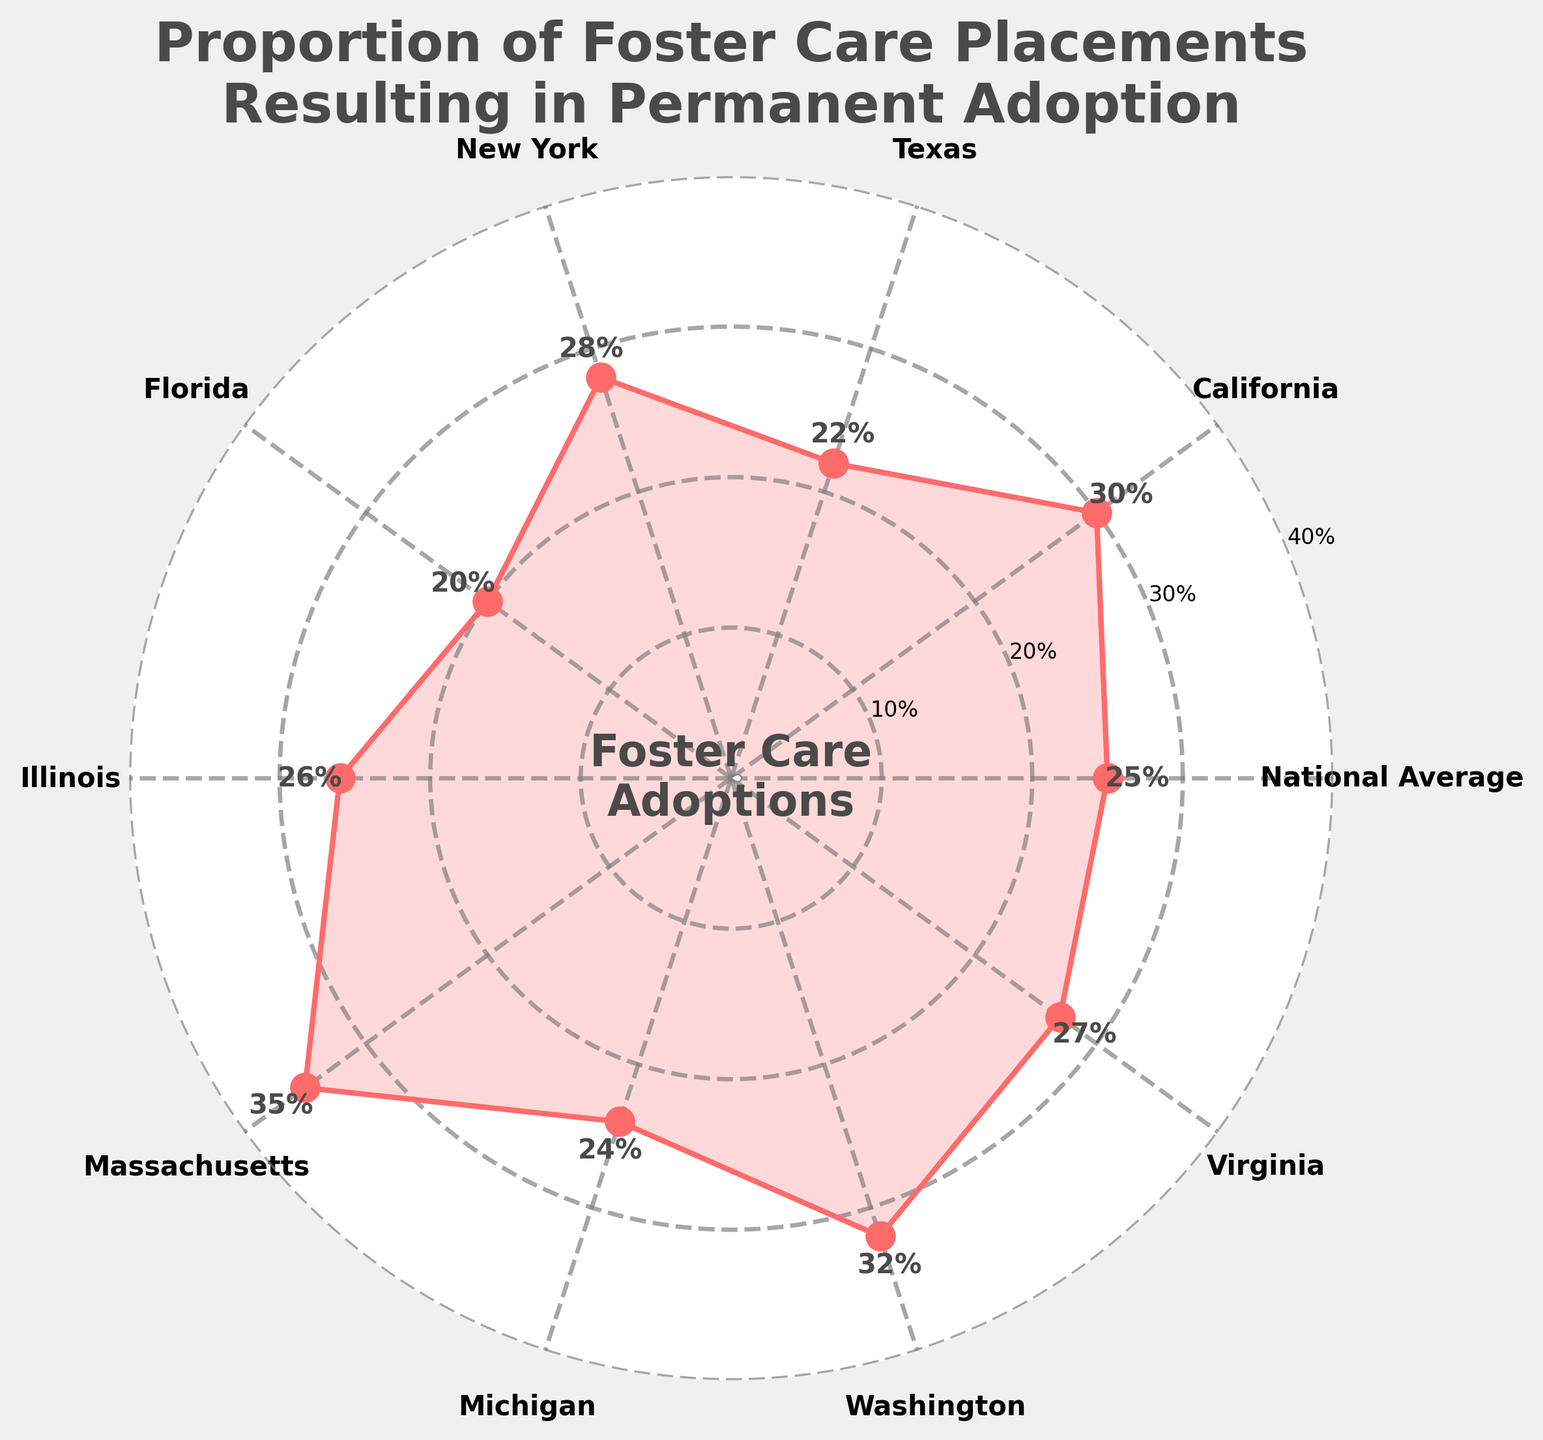what is the title of the figure? The title of the figure is located at the top and it clearly states the purpose of the data visualization.
Answer: Proportion of Foster Care Placements Resulting in Permanent Adoption what is the percentage for Texas? Find the label for Texas on the figure and then look at the associated percentage value displayed near the marker.
Answer: 22% which state has the highest proportion of foster care adoptions? Review each state's percentage of foster care adoptions and identify the one with the highest numerical value.
Answer: Massachusetts how much higher is the adoption rate in California compared to Florida? Locate the percentages for both California and Florida and subtract the value for Florida from that for California to find the difference. 30% (California) - 20% (Florida) = 10%
Answer: 10% what is the average adoption rate across all states shown? Sum up the percentages for all the states and the national average, then divide by the number of entries. (25 + 30 + 22 + 28 + 20 + 26 + 35 + 24 + 32 + 27) / 10 = 26.9%
Answer: 26.9% which state has an adoption rate closest to the national average? Compare the percentage values for each state against the national average of 25% and identify the closest value. Michigan's rate is 24%, which is closest to the national average of 25%.
Answer: Michigan how many states have an adoption rate above 30%? Identify and count the states whose adoption rate values exceed 30% by comparing each state's percentage to 30%.
Answer: 3 states (California, Massachusetts, Washington) are there any states with the same adoption rate? Review the percentages for each state to see if any two or more states have identical values. None of the states have identical adoption rates.
Answer: No 